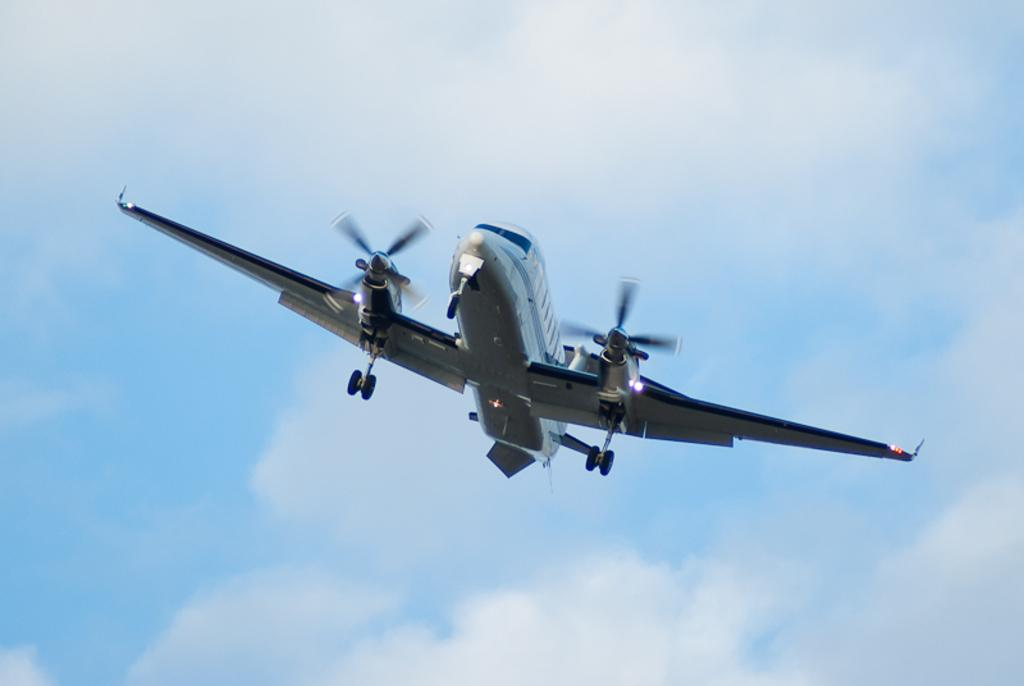What is the main subject of the image? There is an aircraft in the center of the image. What can be seen in the background of the image? The sky is visible in the background of the image. What type of iron can be seen in the image? There is no iron present in the image; it features an aircraft and the sky. 